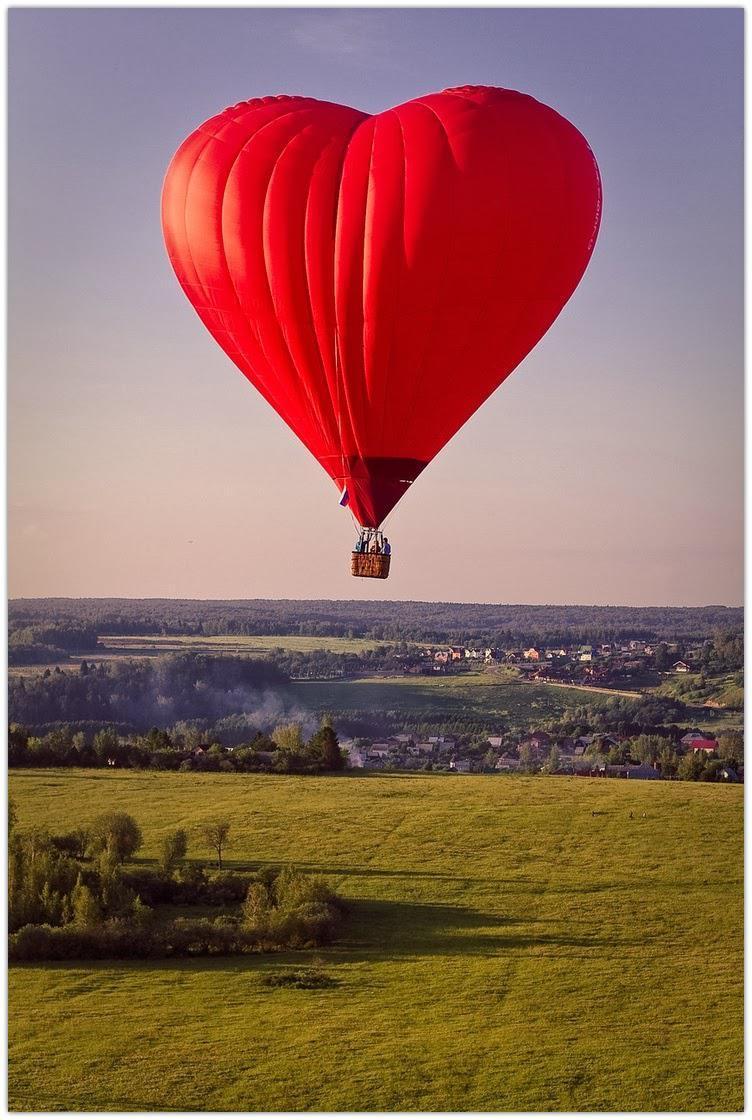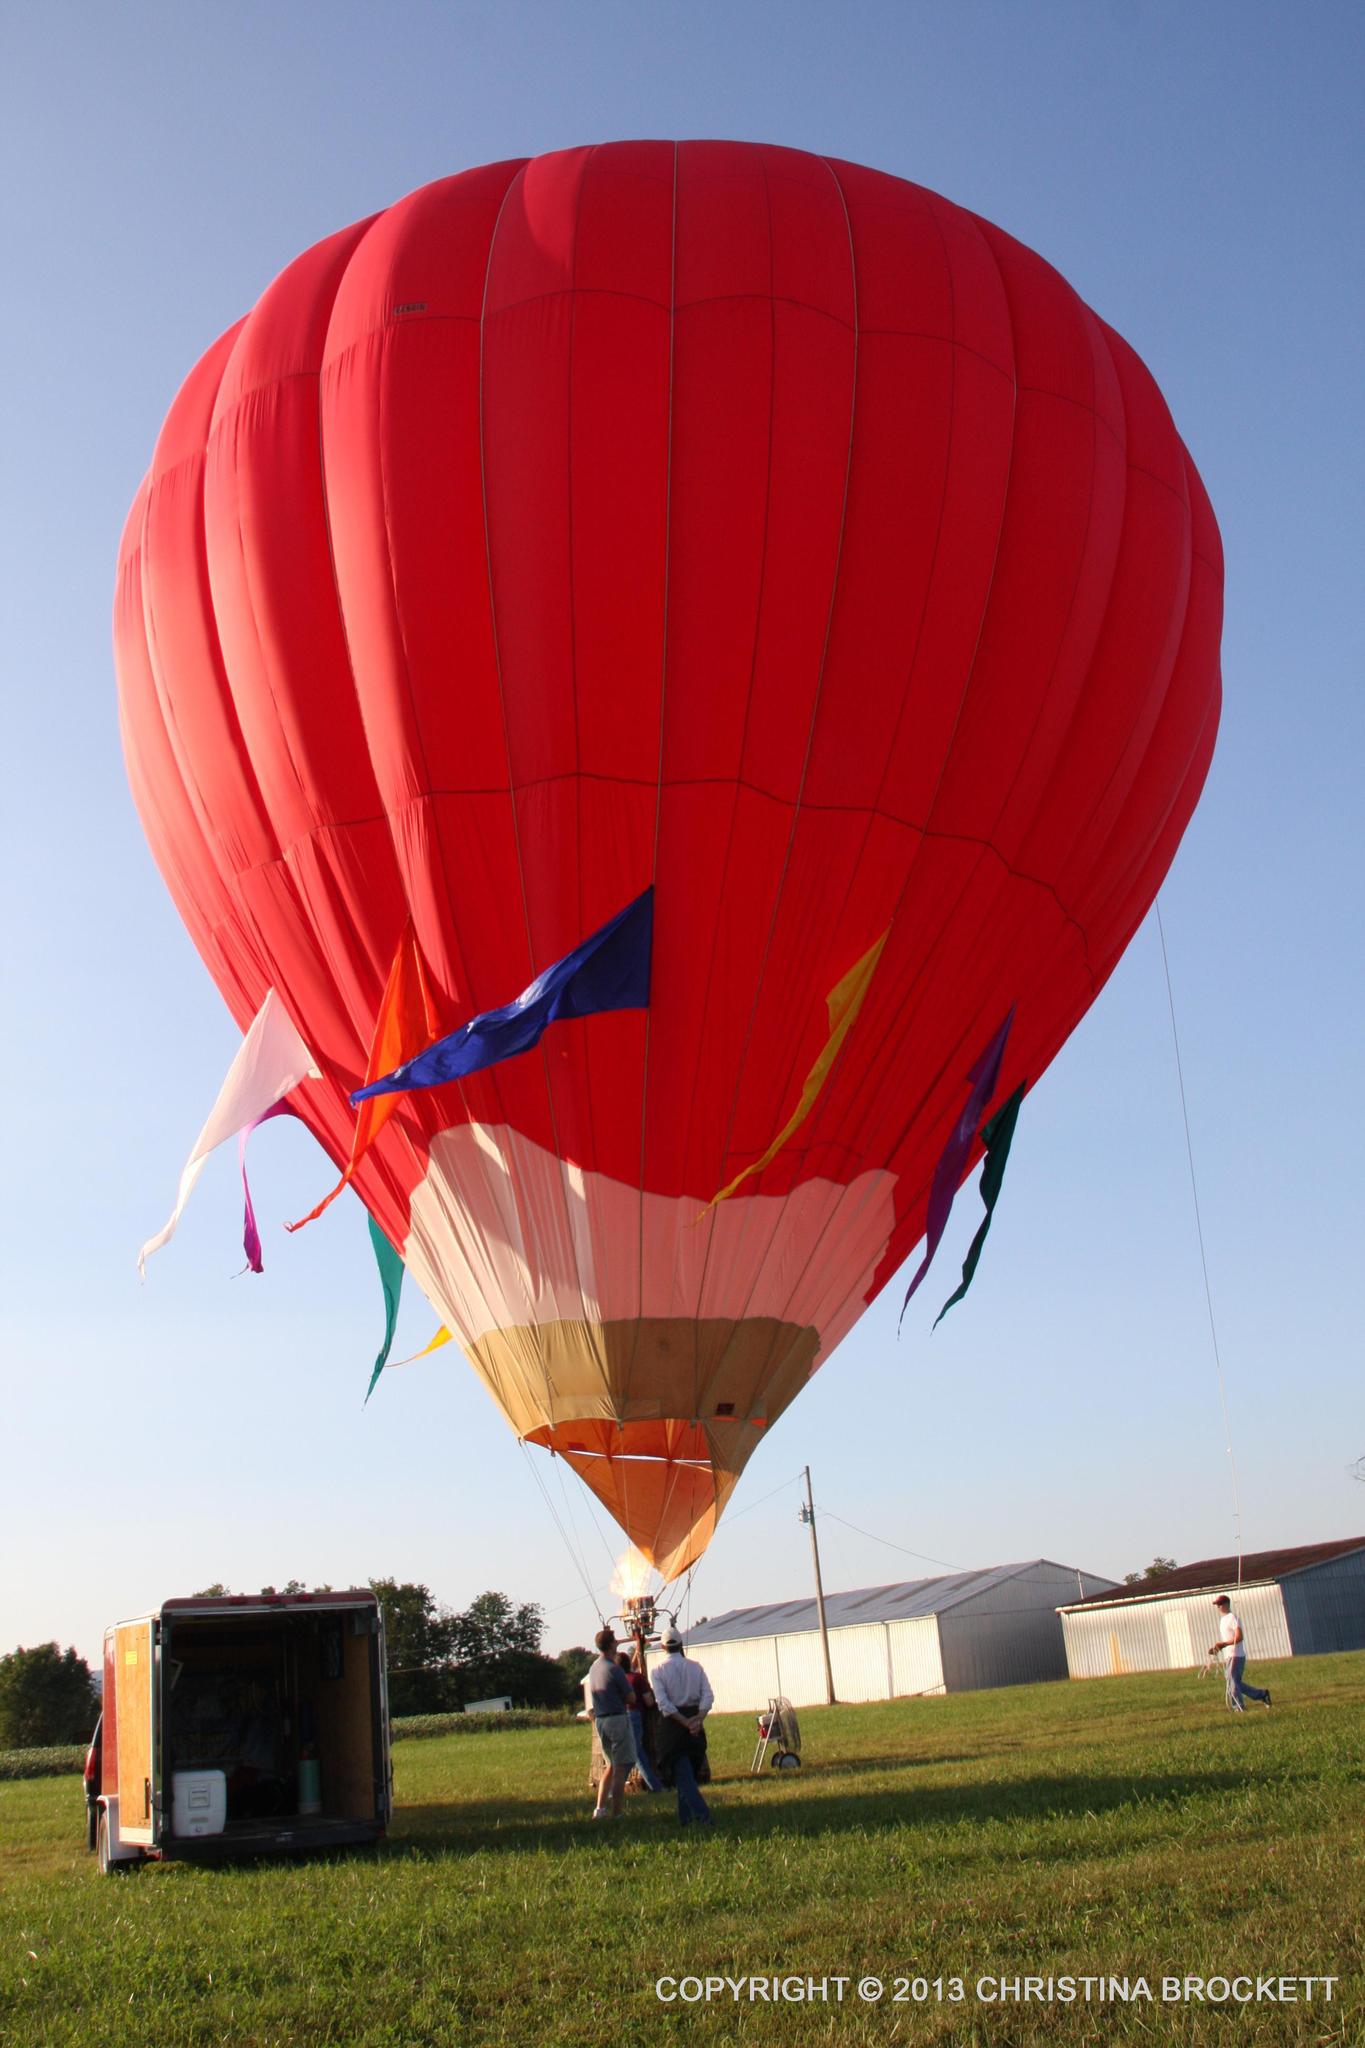The first image is the image on the left, the second image is the image on the right. Evaluate the accuracy of this statement regarding the images: "Two hot air balloons with baskets are floating above ground.". Is it true? Answer yes or no. No. The first image is the image on the left, the second image is the image on the right. Analyze the images presented: Is the assertion "In total, two balloons are in the air rather than on the ground." valid? Answer yes or no. No. 